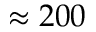Convert formula to latex. <formula><loc_0><loc_0><loc_500><loc_500>\approx 2 0 0</formula> 